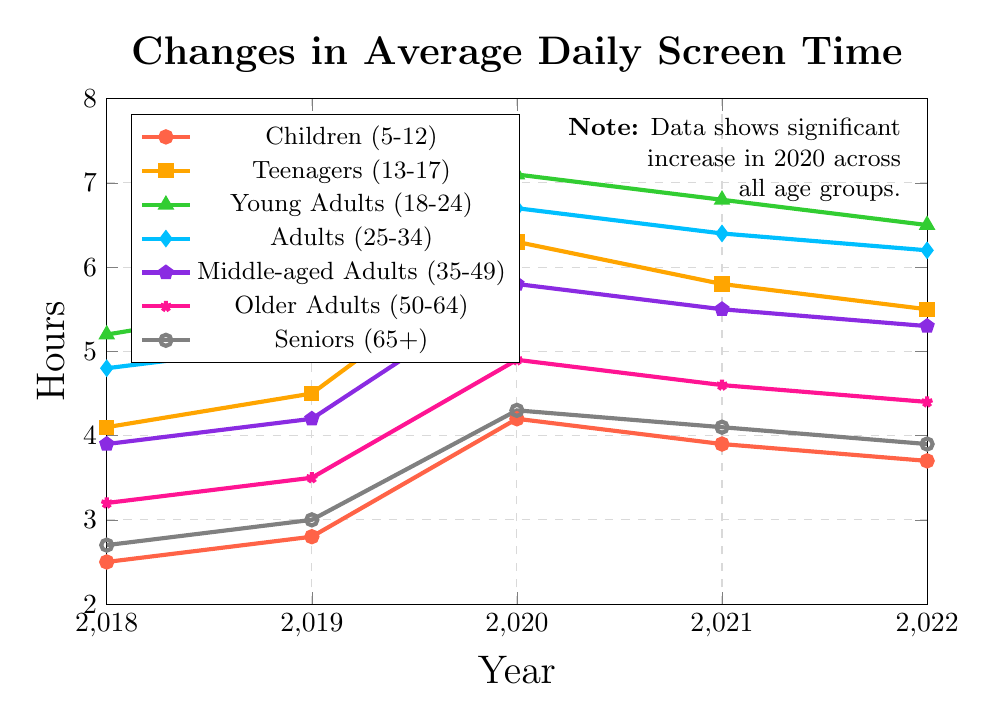What year did each age group experience the highest average daily screen time? To find this, look at the peak of each line in the plot for the various age groups. For Children (5-12), the highest value is in 2020. For Teenagers (13-17), it’s also 2020. Young Adults (18-24) reach their peak in 2020. Adults (25-34), Middle-aged Adults (35-49), Older Adults (50-64), and Seniors (65+) also have their highest screen time in 2020.
Answer: 2020 for all groups Which age group had the highest average daily screen time in 2022? Compare the y-values for each age group at the x-value corresponding to 2022. The highest y-value belongs to Young Adults (18-24).
Answer: Young Adults (18-24) How much did the screen time for Teenagers (13-17) increase from 2018 to 2020? Subtract the screen time value for Teenagers in 2018 from the value in 2020: 6.3 - 4.1 = 2.2.
Answer: 2.2 hours Which two age groups had the closest average daily screen time in 2021? Compare the screen time values for 2021 across all age groups and find the two closest values. Adults (25-34) had 6.4 hours, and Young Adults (18-24) had 6.8 hours, which are closest to each other, with a difference of 0.4 hours.
Answer: Adults (25-34) and Young Adults (18-24) What is the average screen time for Older Adults (50-64) from 2018 to 2022? Add the screen time values for Older Adults over the years (3.2 + 3.5 + 4.9 + 4.6 + 4.4) and divide the sum by the number of years (5): (3.2 + 3.5 + 4.9 + 4.6 + 4.4) / 5 = 4.12.
Answer: 4.12 hours Did any age group have a decrease in average daily screen time from 2020 to 2022? Check the screen time for each group in 2020 and compare it with the value in 2022. All groups show a decrease in screen time between these years.
Answer: Yes, all groups By how much did the screen time of Middle-aged Adults (35-49) change from 2019 to 2022? Find the difference in screen time for Middle-aged Adults between 2019 and 2022: 5.3 - 4.2 = 1.1.
Answer: 1.1 hours Which age group had the lowest screen time consistently from 2018 through 2022? Identify the age group that maintains the lowest screen time values across all years. Children (5-12) and Seniors (65+) have consistently lower values, but Children (5-12) are generally lower each year.
Answer: Children (5-12) What was the overall trend in screen time for Teenagers (13-17) from 2018 to 2022? Starting in 2018 at 4.1, Teenagers’ screen time increases to 6.3 in 2020, but decreases slightly each subsequent year to 5.5 in 2022. The overall trend is upwards, with a peak in 2020, followed by a slight decline.
Answer: Increase, then decrease Compare the screen time of Young Adults (18-24) with Seniors (65+) in 2020. What is the difference? Subtract the screen time of Seniors from Young Adults for the year 2020: 7.1 - 4.3 = 2.8.
Answer: 2.8 hours 